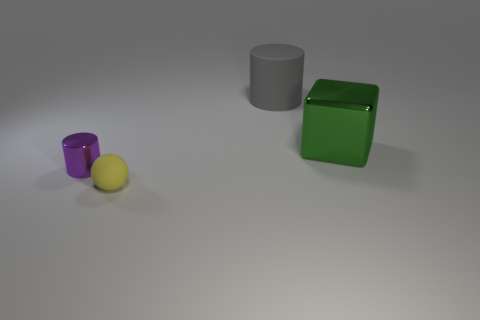Is there a small yellow object that is to the right of the metal object to the right of the big object behind the large green metallic block?
Provide a succinct answer. No. Is the material of the cylinder that is to the right of the small yellow matte sphere the same as the cylinder that is in front of the metallic cube?
Keep it short and to the point. No. What number of things are either green shiny cubes or things that are behind the small yellow object?
Your answer should be very brief. 3. How many metal things have the same shape as the large gray matte thing?
Offer a terse response. 1. There is a object that is the same size as the ball; what material is it?
Give a very brief answer. Metal. What is the size of the cylinder to the left of the big thing on the left side of the shiny thing that is on the right side of the purple cylinder?
Keep it short and to the point. Small. Do the small object that is in front of the small purple shiny cylinder and the rubber thing behind the big green object have the same color?
Offer a terse response. No. How many green things are big metal things or shiny cylinders?
Keep it short and to the point. 1. What number of red cubes are the same size as the gray matte object?
Provide a succinct answer. 0. Do the small yellow ball in front of the rubber cylinder and the purple thing have the same material?
Make the answer very short. No. 